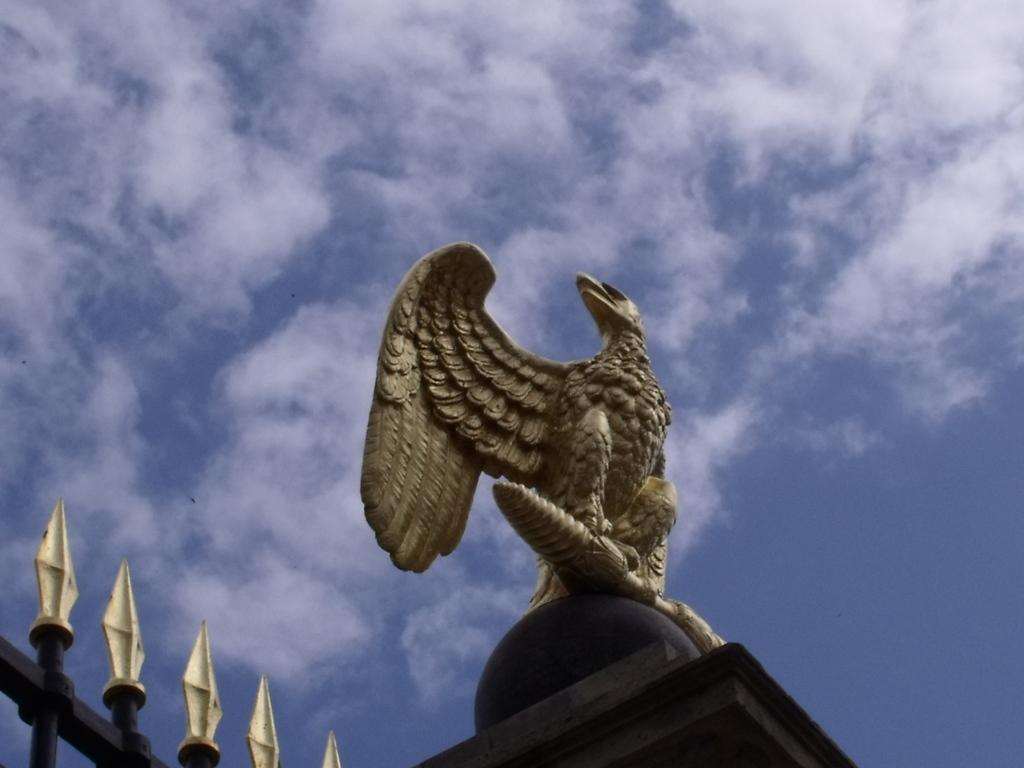What is the main subject in the foreground of the image? There is an eagle statue in the foreground of the image. What structure can be seen in the image? There is a gate in the image. What type of location is depicted in the image? There is a cemetery in the image. What can be seen in the background of the image? The sky is visible in the background of the image. What type of quartz can be seen in the partner's hand? There is no quartz or partner present in the image. How is the chalk being used in the image? There is no chalk present in the image. 